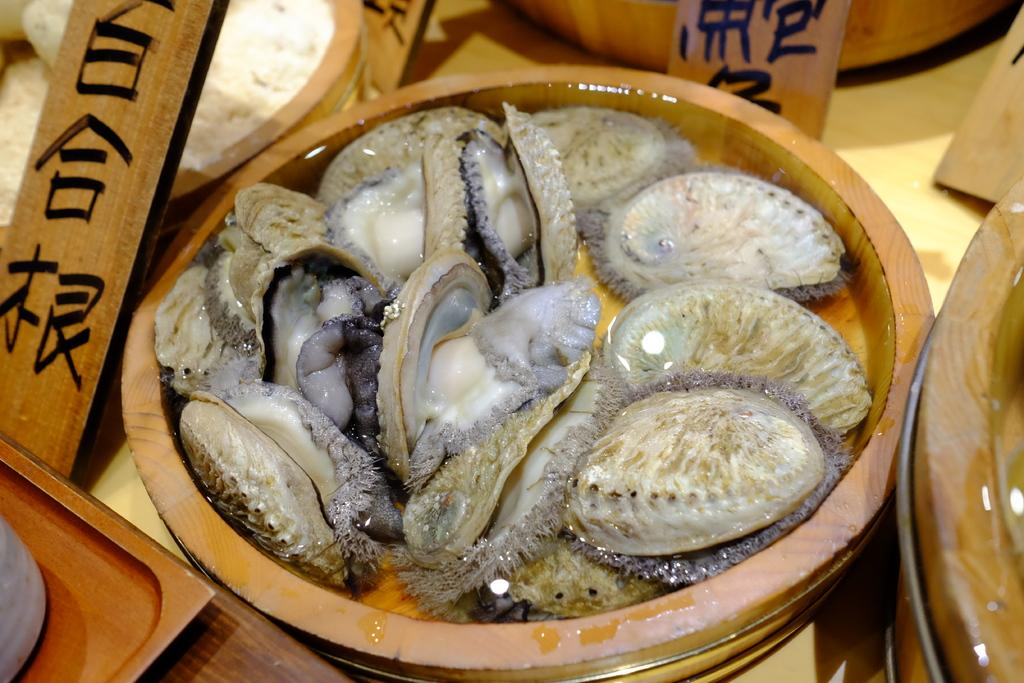What type of seafood is in the bowl in the image? There are oysters in a bowl in the image. What piece of furniture is present in the image? There is a table in the image. What material are the bowls made of? The bowls on the table are made of wood. What else is on the table besides the bowls? There are boards on the table. What type of harmony can be heard in the image? There is no audible sound or music in the image, so it is not possible to determine the type of harmony. 